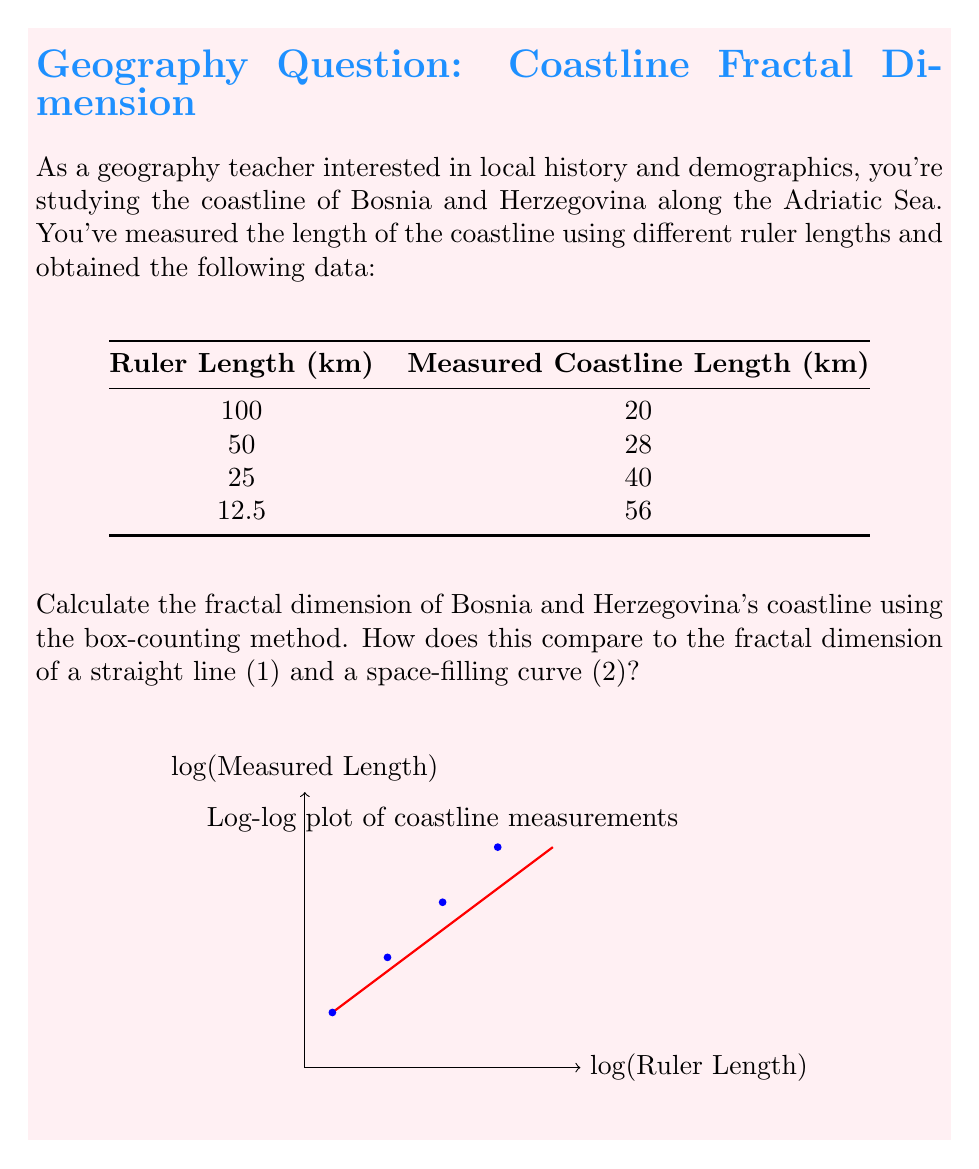Could you help me with this problem? To calculate the fractal dimension using the box-counting method, we need to use the relationship:

$$ N(r) \propto r^{-D} $$

where $N(r)$ is the number of boxes of side length $r$ needed to cover the coastline, and $D$ is the fractal dimension.

Taking logarithms of both sides:

$$ \log N(r) = -D \log r + C $$

This is a linear equation where $-D$ is the slope.

In our case, we have the measured length $L(r)$ for different ruler lengths $r$. The number of boxes $N(r)$ is proportional to $L(r)/r$, so we can use $L(r)/r$ instead of $N(r)$ in our calculations.

Steps:
1) Create a table with $\log r$ and $\log(L(r)/r)$:

   $\log r$ | $\log(L(r)/r)$
   ---------|---------------
   4.61     | -1.61
   3.91     | -0.58
   3.22     | 0.47
   2.53     | 1.50

2) Plot these points (as shown in the graph in the question).

3) Find the slope of the best-fit line. We can use the first and last points for an approximation:

   $$ D = -\frac{\Delta \log(L(r)/r)}{\Delta \log r} = -\frac{1.50 - (-1.61)}{2.53 - 4.61} = \frac{3.11}{-2.08} \approx 1.49 $$

4) The fractal dimension is approximately 1.49.

This value is between 1 (a straight line) and 2 (a space-filling curve), indicating that Bosnia and Herzegovina's coastline is more complex than a straight line but doesn't fill the plane completely.
Answer: $D \approx 1.49$ 